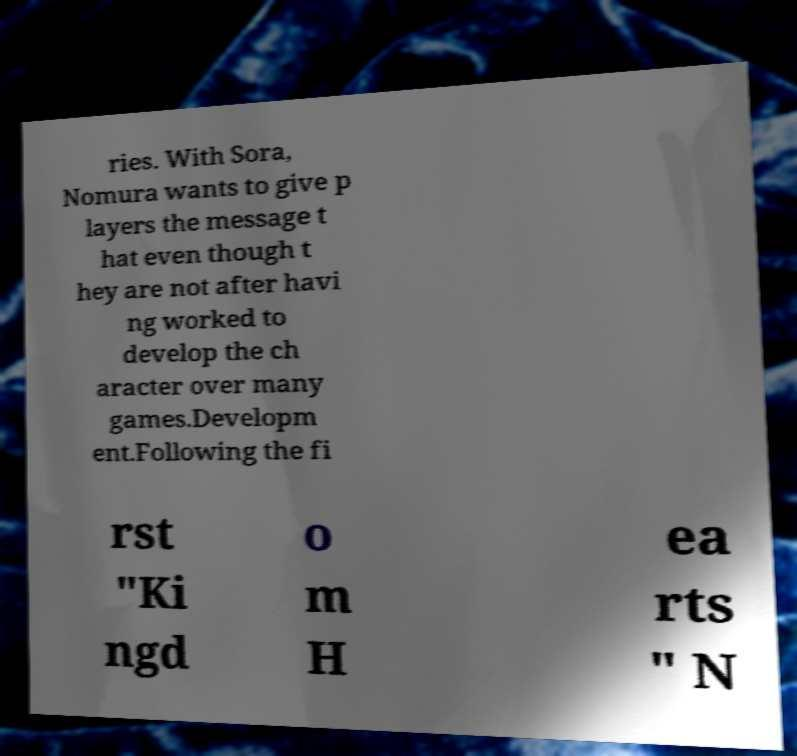Could you assist in decoding the text presented in this image and type it out clearly? ries. With Sora, Nomura wants to give p layers the message t hat even though t hey are not after havi ng worked to develop the ch aracter over many games.Developm ent.Following the fi rst "Ki ngd o m H ea rts " N 